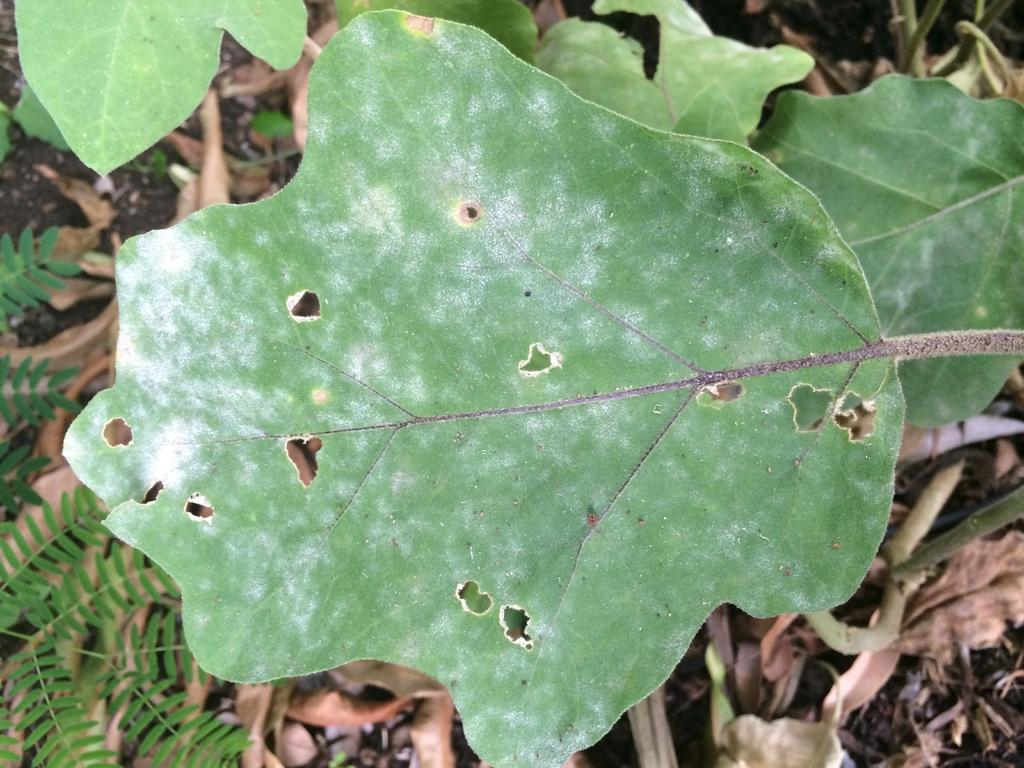What type of vegetation can be seen in the image? There are leaves in the image. How many roses can be seen in the image? There are no roses present in the image; only leaves are visible. What attempt is being made by the leaves in the image? The leaves are not attempting anything in the image; they are simply present as vegetation. 